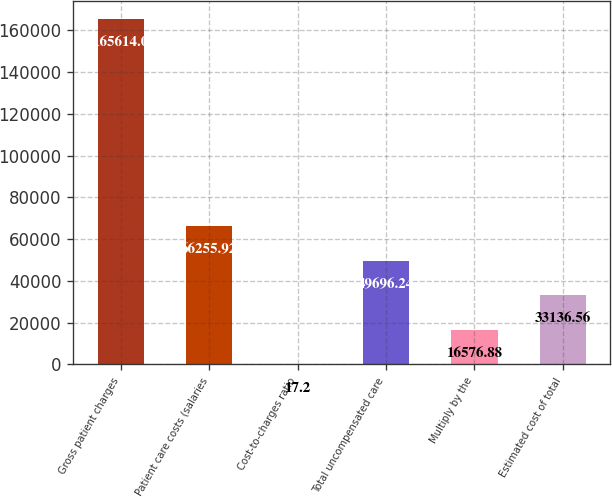<chart> <loc_0><loc_0><loc_500><loc_500><bar_chart><fcel>Gross patient charges<fcel>Patient care costs (salaries<fcel>Cost-to-charges ratio<fcel>Total uncompensated care<fcel>Multiply by the<fcel>Estimated cost of total<nl><fcel>165614<fcel>66255.9<fcel>17.2<fcel>49696.2<fcel>16576.9<fcel>33136.6<nl></chart> 